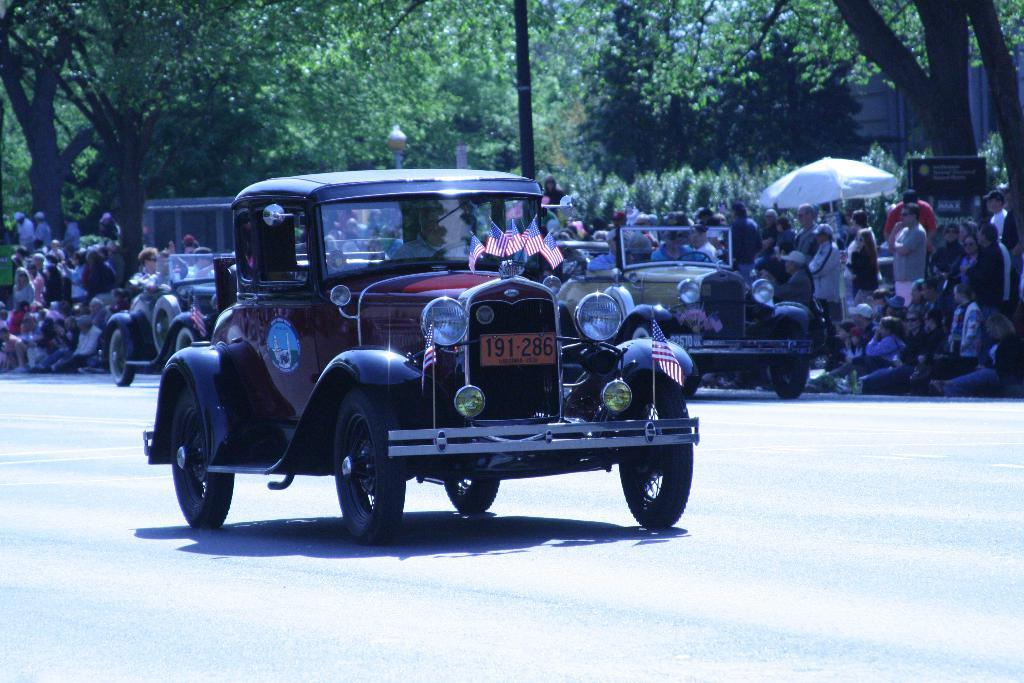What type of vehicles can be seen on the road in the image? There are cars on the road in the image. What are some people doing in the image? Some people are sitting on the road, while others are standing. What can be seen in the distance in the image? There are trees visible in the background of the image. What type of attention is the cemetery receiving in the image? There is no cemetery present in the image, so it is not possible to determine what type of attention it might be receiving. 